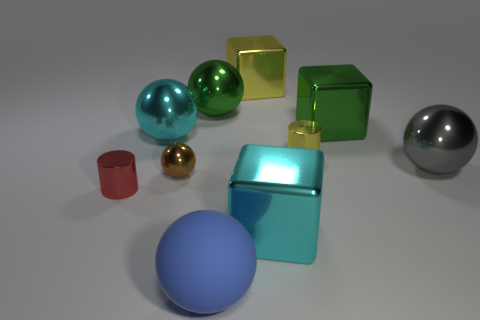How many objects are either large yellow objects or cyan metal blocks?
Your response must be concise. 2. What color is the rubber sphere that is the same size as the cyan block?
Your answer should be compact. Blue. How many things are either green metal things that are to the left of the cyan block or small brown spheres?
Your response must be concise. 2. How many other things are there of the same size as the cyan shiny sphere?
Offer a very short reply. 6. How big is the green shiny object to the left of the tiny yellow thing?
Your response must be concise. Large. The gray thing that is the same material as the big green ball is what shape?
Give a very brief answer. Sphere. Is there anything else that is the same color as the large matte thing?
Offer a terse response. No. What color is the cylinder on the left side of the cyan thing in front of the tiny shiny ball?
Provide a short and direct response. Red. What number of tiny objects are purple shiny blocks or gray objects?
Your answer should be very brief. 0. What material is the large blue object that is the same shape as the brown metal thing?
Your response must be concise. Rubber. 